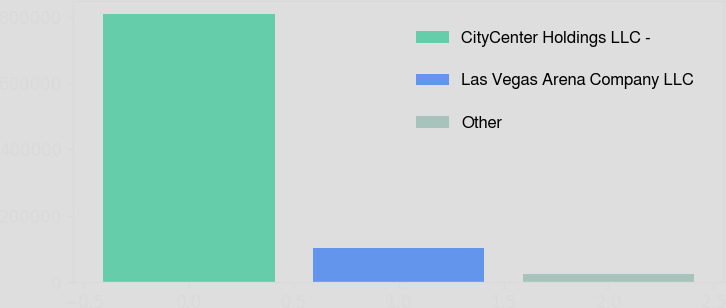<chart> <loc_0><loc_0><loc_500><loc_500><bar_chart><fcel>CityCenter Holdings LLC -<fcel>Las Vegas Arena Company LLC<fcel>Other<nl><fcel>808220<fcel>102526<fcel>24116<nl></chart> 